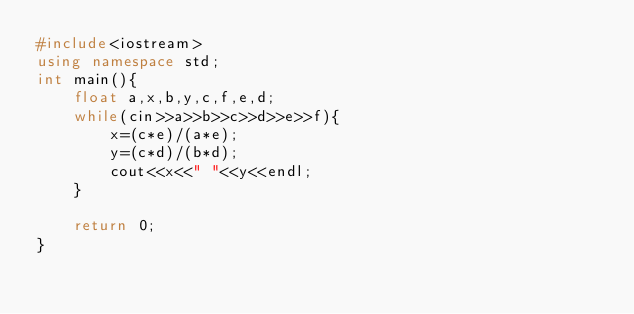Convert code to text. <code><loc_0><loc_0><loc_500><loc_500><_C++_>#include<iostream>
using namespace std;
int main(){
    float a,x,b,y,c,f,e,d;
    while(cin>>a>>b>>c>>d>>e>>f){
        x=(c*e)/(a*e);
        y=(c*d)/(b*d);
        cout<<x<<" "<<y<<endl;
    }
    
    return 0;
}</code> 